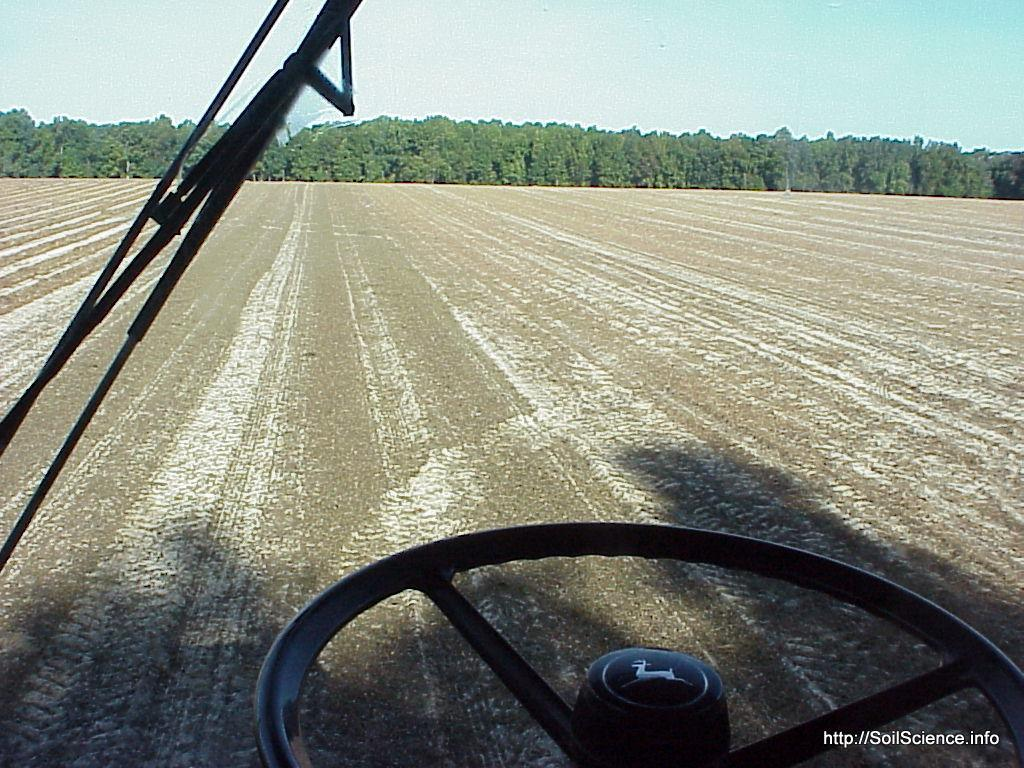What is the perspective of the image? The image is taken from a vehicle. What type of vegetation can be seen in the image? There are trees and plants in the image. What type of scarecrow can be seen in the image? There is no scarecrow present in the image. How many bees are buzzing around the plants in the image? There is no mention of bees in the image, so we cannot determine their presence or quantity. 